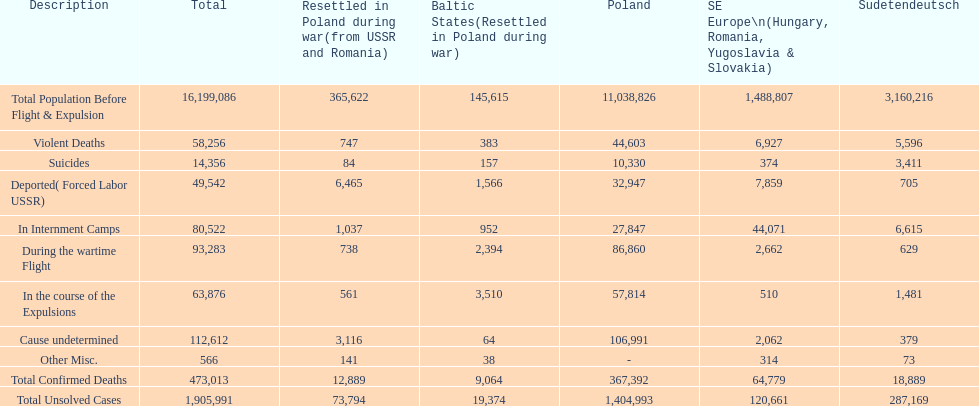Across all regions, what is the sum of violent deaths? 58,256. 